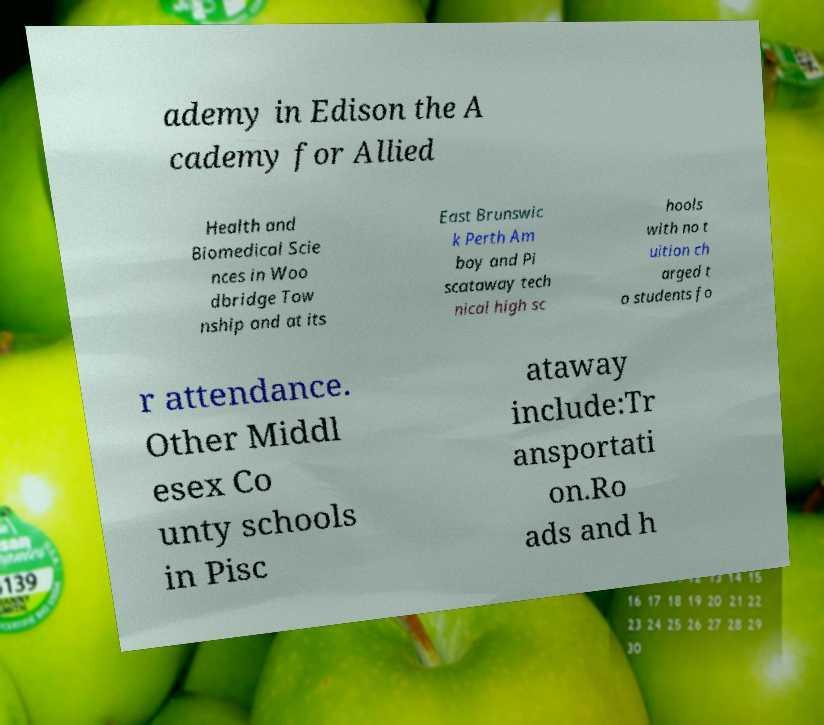Could you extract and type out the text from this image? ademy in Edison the A cademy for Allied Health and Biomedical Scie nces in Woo dbridge Tow nship and at its East Brunswic k Perth Am boy and Pi scataway tech nical high sc hools with no t uition ch arged t o students fo r attendance. Other Middl esex Co unty schools in Pisc ataway include:Tr ansportati on.Ro ads and h 